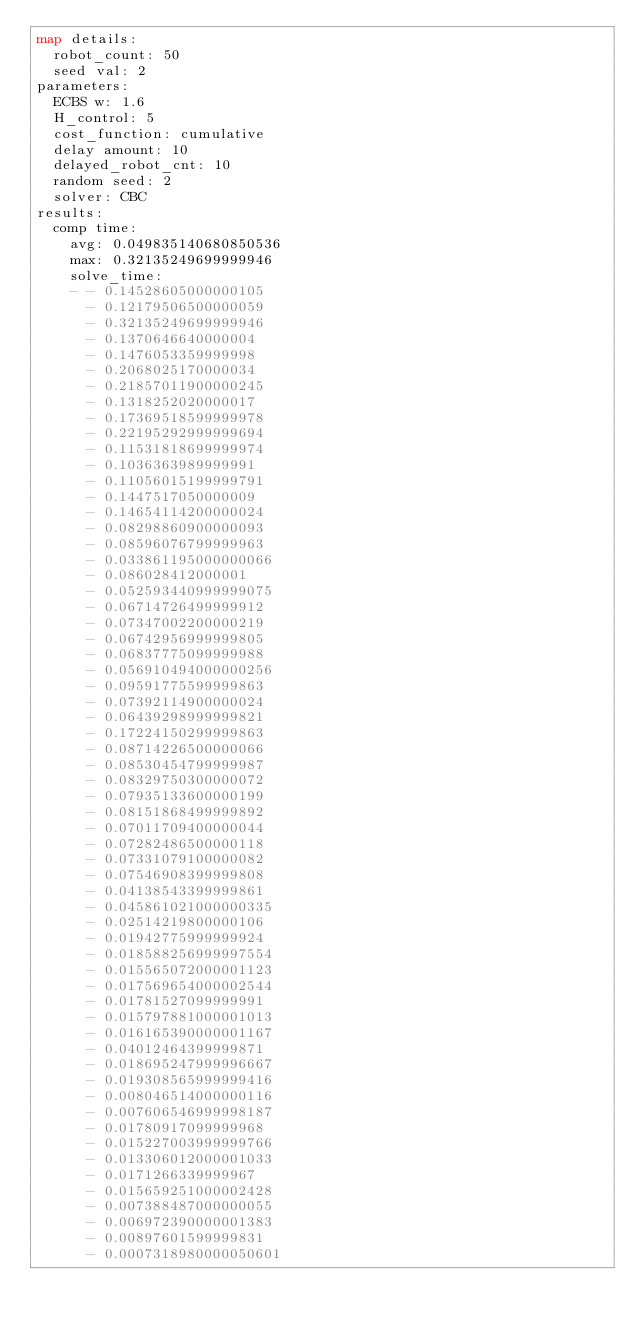<code> <loc_0><loc_0><loc_500><loc_500><_YAML_>map details:
  robot_count: 50
  seed val: 2
parameters:
  ECBS w: 1.6
  H_control: 5
  cost_function: cumulative
  delay amount: 10
  delayed_robot_cnt: 10
  random seed: 2
  solver: CBC
results:
  comp time:
    avg: 0.049835140680850536
    max: 0.32135249699999946
    solve_time:
    - - 0.14528605000000105
      - 0.12179506500000059
      - 0.32135249699999946
      - 0.1370646640000004
      - 0.1476053359999998
      - 0.2068025170000034
      - 0.21857011900000245
      - 0.1318252020000017
      - 0.17369518599999978
      - 0.22195292999999694
      - 0.11531818699999974
      - 0.1036363989999991
      - 0.11056015199999791
      - 0.1447517050000009
      - 0.14654114200000024
      - 0.08298860900000093
      - 0.08596076799999963
      - 0.033861195000000066
      - 0.086028412000001
      - 0.052593440999999075
      - 0.06714726499999912
      - 0.07347002200000219
      - 0.06742956999999805
      - 0.06837775099999988
      - 0.056910494000000256
      - 0.09591775599999863
      - 0.07392114900000024
      - 0.06439298999999821
      - 0.17224150299999863
      - 0.08714226500000066
      - 0.08530454799999987
      - 0.08329750300000072
      - 0.07935133600000199
      - 0.08151868499999892
      - 0.07011709400000044
      - 0.07282486500000118
      - 0.07331079100000082
      - 0.07546908399999808
      - 0.04138543399999861
      - 0.045861021000000335
      - 0.02514219800000106
      - 0.01942775999999924
      - 0.018588256999997554
      - 0.015565072000001123
      - 0.017569654000002544
      - 0.01781527099999991
      - 0.015797881000001013
      - 0.016165390000001167
      - 0.04012464399999871
      - 0.018695247999996667
      - 0.019308565999999416
      - 0.008046514000000116
      - 0.007606546999998187
      - 0.01780917099999968
      - 0.015227003999999766
      - 0.013306012000001033
      - 0.0171266339999967
      - 0.015659251000002428
      - 0.007388487000000055
      - 0.006972390000001383
      - 0.00897601599999831
      - 0.0007318980000050601</code> 